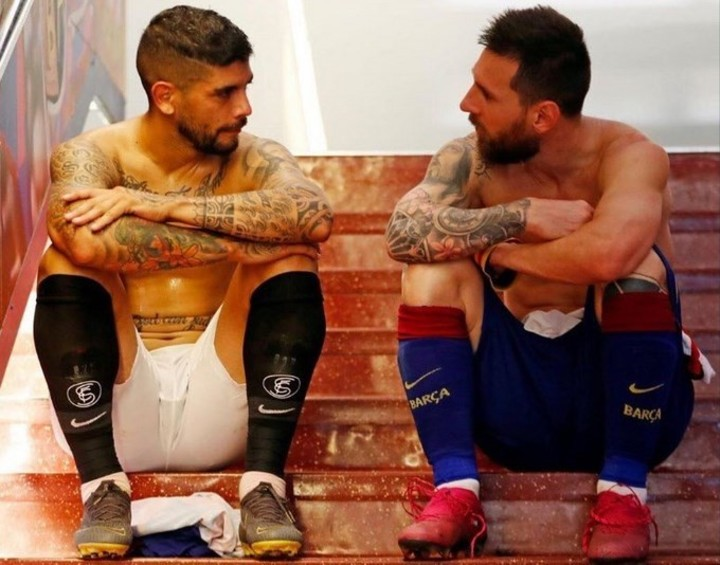By analyzing the body language and facial expressions, what could be the nature of the conversation between the two players? The body language and facial expressions of the two players indicate a serious and introspective dialogue. The player on the left is looking down and away, with his arms crossed and hands tucked under his arms. This position often suggests a reflective or self-contained state. The player on the right is leaning forward slightly, with one hand supporting his weight and the other hand brought to his mouth, a gesture that often indicates thoughtfulness or concern. The lack of direct eye contact further implies that the conversation might be contemplative or sensitive in nature, possibly involving performance, team dynamics, or personal matters related to their sport. It seems like a moment of shared reflection and mutual understanding, highlighting the depth and intensity often present in sports interactions. 